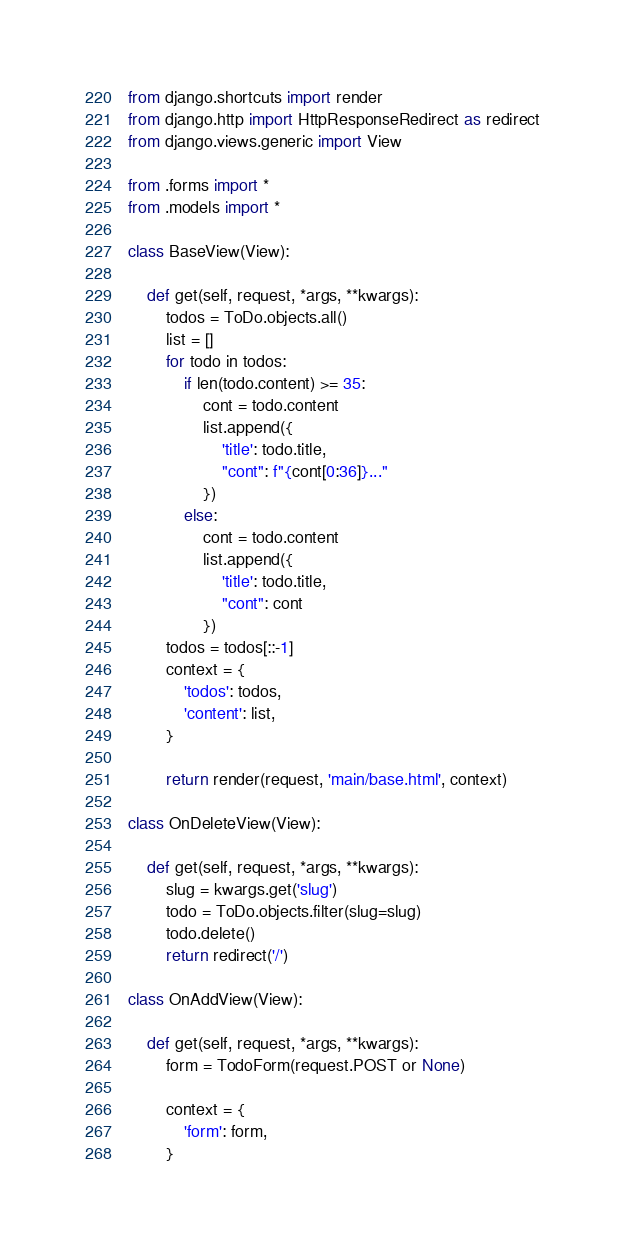Convert code to text. <code><loc_0><loc_0><loc_500><loc_500><_Python_>from django.shortcuts import render
from django.http import HttpResponseRedirect as redirect
from django.views.generic import View

from .forms import *
from .models import *

class BaseView(View):

    def get(self, request, *args, **kwargs):
        todos = ToDo.objects.all()
        list = []
        for todo in todos:
            if len(todo.content) >= 35:
                cont = todo.content
                list.append({
                    'title': todo.title,
                    "cont": f"{cont[0:36]}..."
                })
            else:
                cont = todo.content
                list.append({
                    'title': todo.title,
                    "cont": cont
                })
        todos = todos[::-1]
        context = {
            'todos': todos,
            'content': list,
        }

        return render(request, 'main/base.html', context)

class OnDeleteView(View):

    def get(self, request, *args, **kwargs):
        slug = kwargs.get('slug')
        todo = ToDo.objects.filter(slug=slug)
        todo.delete()
        return redirect('/')

class OnAddView(View):

    def get(self, request, *args, **kwargs):
        form = TodoForm(request.POST or None)

        context = {
            'form': form,
        }</code> 